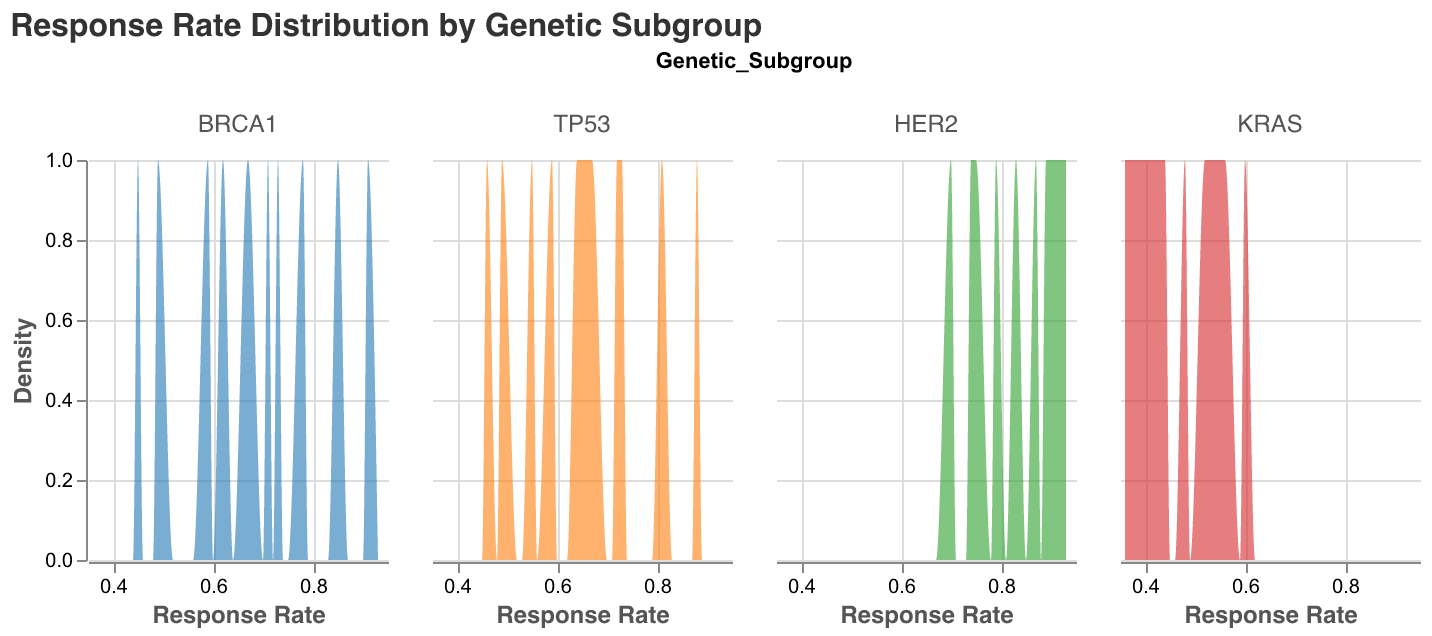What is the title of the plot? The title of the plot is displayed at the top in a larger font size to summarize the overall content.
Answer: Response Rate Distribution by Genetic Subgroup How many genetic subgroups are displayed in the plot? The plot shows a facet of density plots categorized by different genetic subgroups. By counting the number of individual plots, we can see there are four genetic subgroups.
Answer: 4 Which genetic subgroup appears to have the highest peak density in the plot? By observing the height of the peak in each density plot, the HER2 subgroup has the highest peak, indicating a higher concentration of response rates around its mode.
Answer: HER2 What is the range of response rates for the BRCA1 subgroup? From the x-axis of the BRCA1 density plot, the response rates span from the minimum to the maximum values denoted on the axis.
Answer: 0.45 to 0.91 Which genetic subgroup shows the lowest response rate in the plot? By examining the x-axes of all the density plots and identifying the smallest value, KRAS shows the lowest response rate.
Answer: KRAS Which genetic subgroup has the most spread-out distribution of response rates? A more spread-out distribution will have a wider base. The KRAS subgroup shows a broader base, indicating more variability in its response rates.
Answer: KRAS Between BRCA1 and TP53, which subgroup has a higher mean response rate? The mean response rate can be inferred by the central tendency of the peaks. BRCA1 has a peak shifted more toward higher values compared to TP53.
Answer: BRCA1 How does the variability in response rates compare between HER2 and KRAS subgroups? Variability can be gauged by the width of the distribution. The KRAS subgroup shows greater variability with a wider and flatter distribution compared to the narrower and higher density of HER2.
Answer: KRAS shows greater variability What can you infer about the common response rates for HER2 subgroup based on its density plot? The density plot for HER2 indicates that most response rates cluster around higher values, as evidenced by the higher peaks near the upper end of the x-axis.
Answer: Higher response rates common Which genetic subgroup has a density plot indicating a unimodal distribution? Unimodal distribution means having a single clear peak. Both HER2 and BRCA1 subgroups show unimodal distribution.
Answer: HER2, BRCA1 